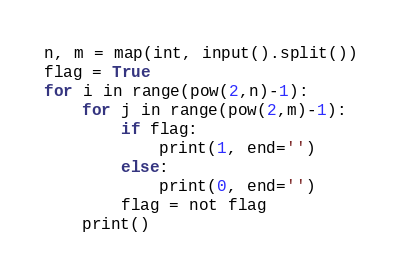<code> <loc_0><loc_0><loc_500><loc_500><_Python_>n, m = map(int, input().split())
flag = True
for i in range(pow(2,n)-1):
    for j in range(pow(2,m)-1):
        if flag:
            print(1, end='')
        else:
            print(0, end='')
        flag = not flag
    print()</code> 